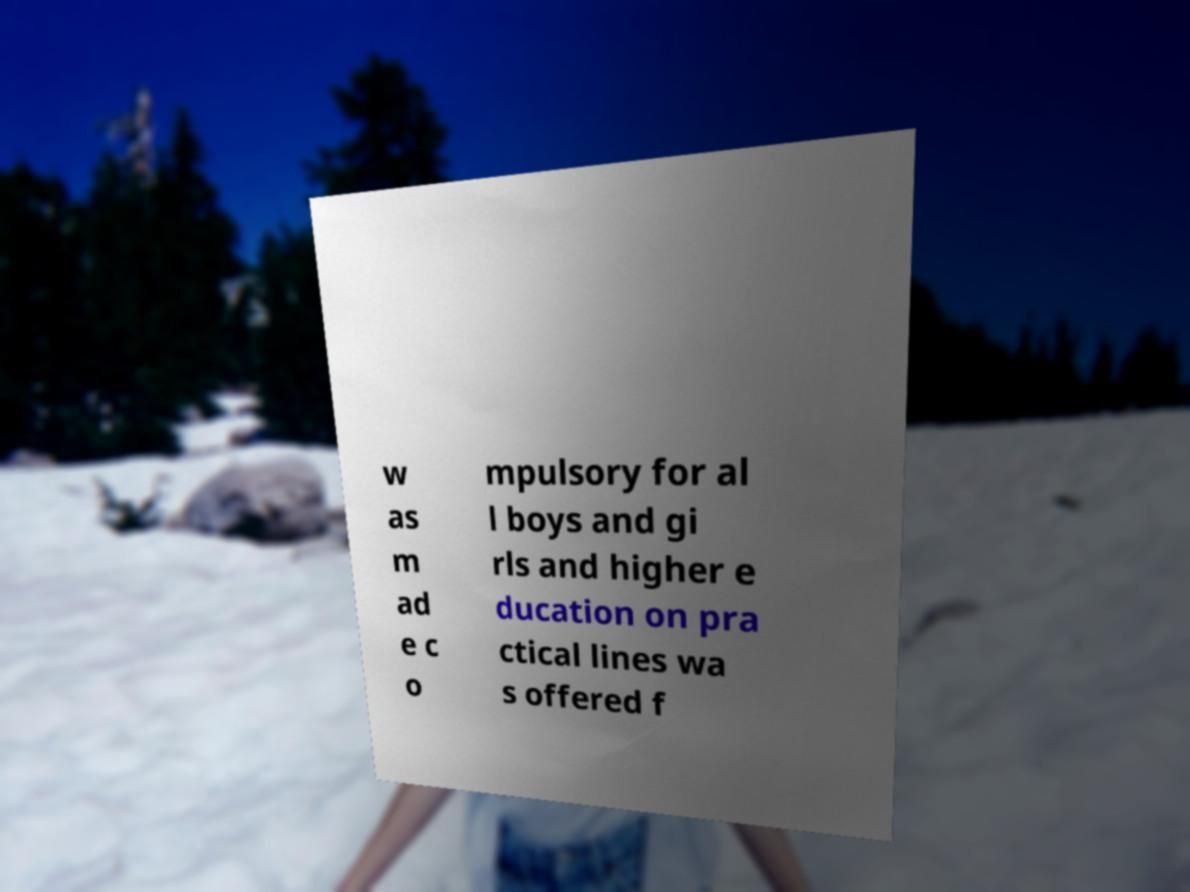For documentation purposes, I need the text within this image transcribed. Could you provide that? w as m ad e c o mpulsory for al l boys and gi rls and higher e ducation on pra ctical lines wa s offered f 